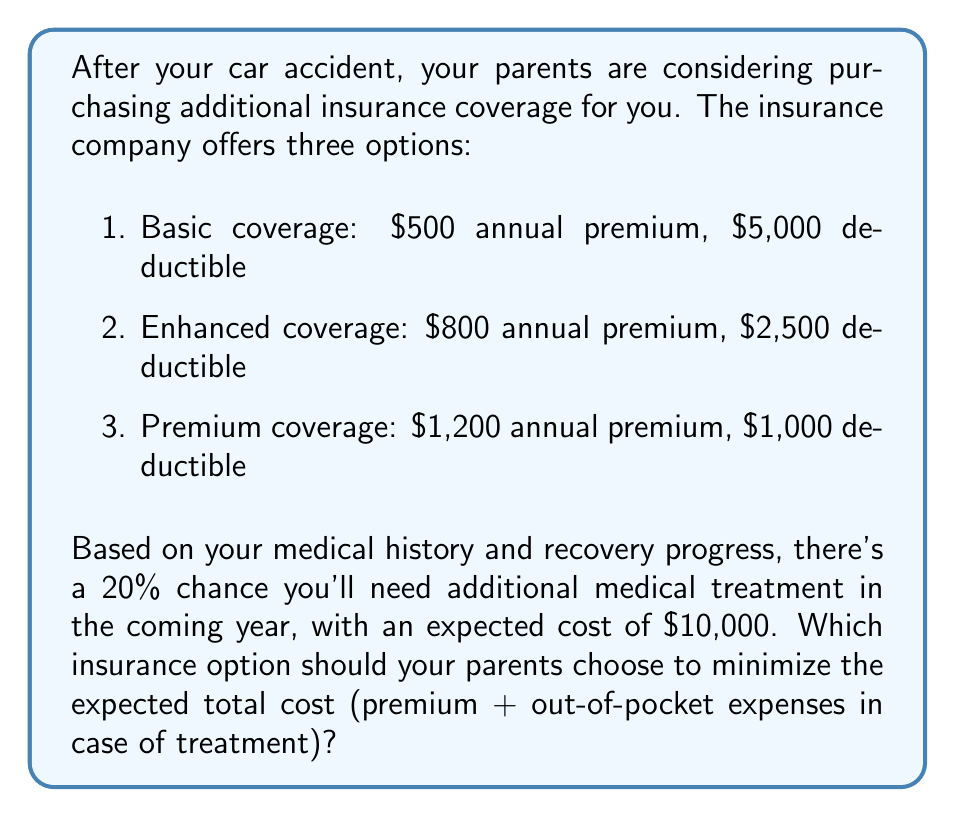Can you solve this math problem? To solve this problem, we need to calculate the expected total cost for each insurance option using expected value analysis. The expected total cost is the sum of the annual premium and the expected out-of-pocket expense.

Let's calculate the expected total cost for each option:

1. Basic coverage:
   Premium: $500
   Expected out-of-pocket: $0.2 \times \min($10,000, $5,000) = $0.2 \times $5,000 = $1,000
   Expected total cost: $500 + $1,000 = $1,500

2. Enhanced coverage:
   Premium: $800
   Expected out-of-pocket: $0.2 \times \min($10,000, $2,500) = $0.2 \times $2,500 = $500
   Expected total cost: $800 + $500 = $1,300

3. Premium coverage:
   Premium: $1,200
   Expected out-of-pocket: $0.2 \times \min($10,000, $1,000) = $0.2 \times $1,000 = $200
   Expected total cost: $1,200 + $200 = $1,400

The expected total cost is calculated using the formula:

$$ E[\text{Total Cost}] = \text{Premium} + p \times \min(\text{Treatment Cost}, \text{Deductible}) $$

where $p$ is the probability of needing treatment (20% or 0.2 in this case).

Comparing the expected total costs:
Enhanced coverage: $1,300
Premium coverage: $1,400
Basic coverage: $1,500

The enhanced coverage option has the lowest expected total cost.
Answer: Your parents should choose the enhanced coverage option with an $800 annual premium and $2,500 deductible, as it minimizes the expected total cost at $1,300. 